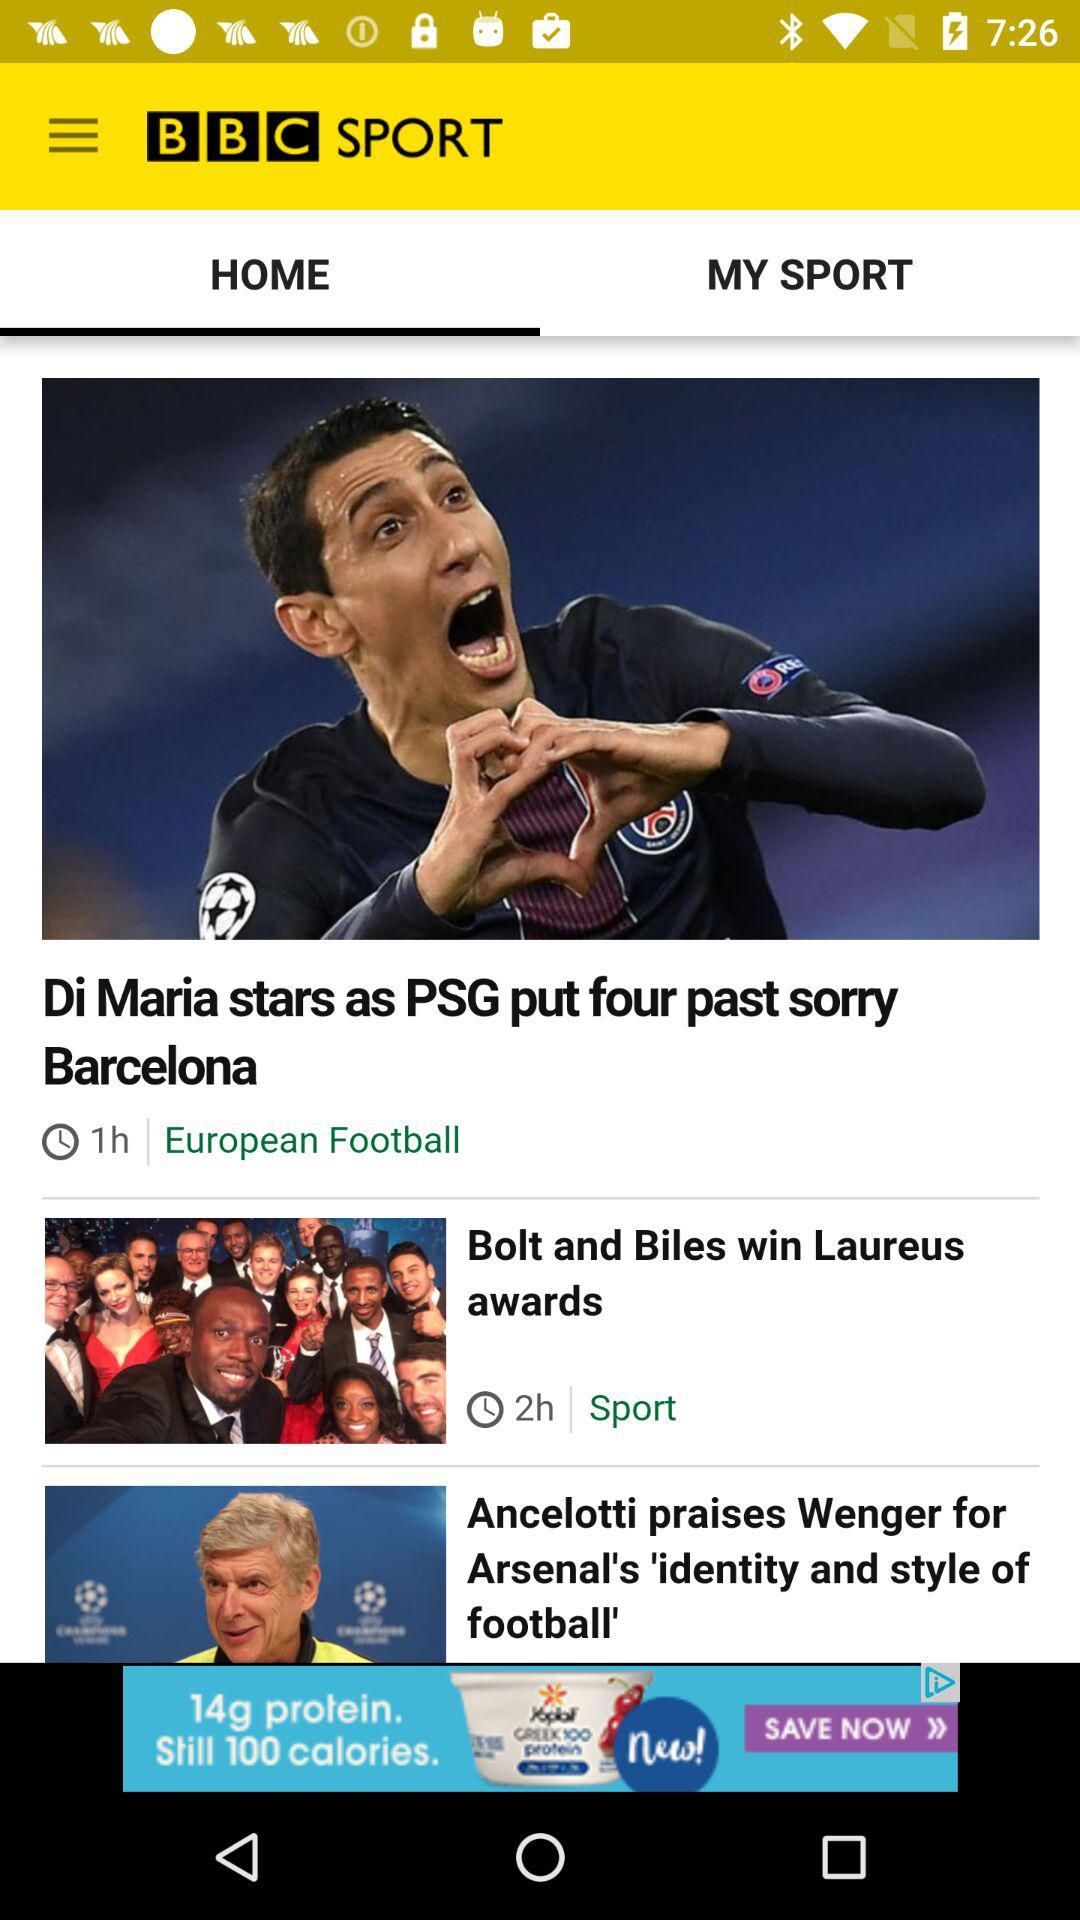What is the selected tab? The selected tab is "HOME". 